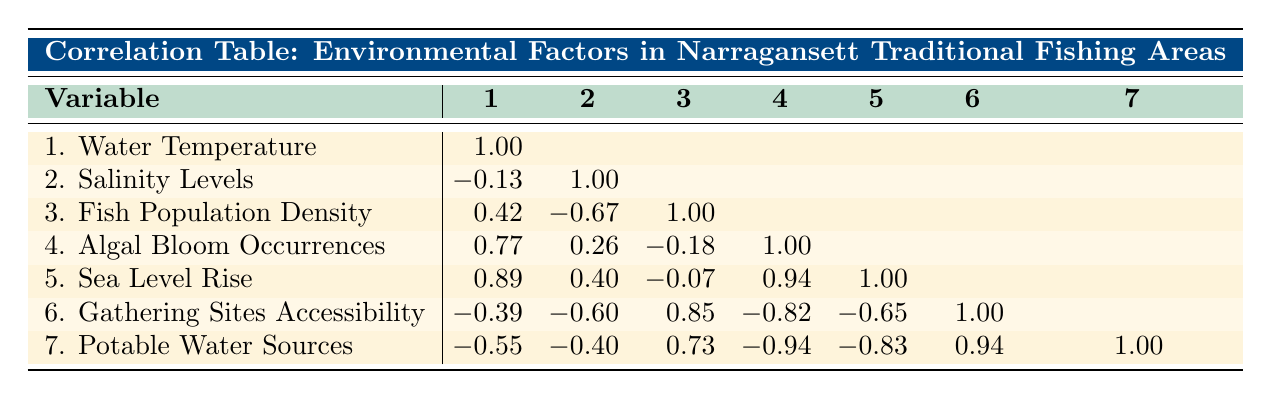What's the fish population density in Narrow River? In the table, under the column for fish population density, I see that the value corresponding to Narrow River is 200 fish per square mile.
Answer: 200 What is the salinity level of Point Judith Pond? Point Judith Pond shows a salinity level of 27 PSU in the salinity levels column of the table.
Answer: 27 Which fishing area has the highest water temperature? By observing the water temperature values for each fishing area, Matunuck Beach has the highest water temperature at 67 degrees Fahrenheit.
Answer: 67 Is there a correlation between fish population density and gathering sites accessibility? Looking at the correlation table, I see that the correlation coefficient between fish population density and gathering sites accessibility is 0.85, indicating a strong positive correlation.
Answer: Yes What is the sea level rise associated with Narragansett Bay? I can find the value for sea level rise next to Narragansett Bay under the sea level rise column, which is 1.2 feet per year.
Answer: 1.2 What is the average number of algal bloom occurrences across all fishing areas? I can calculate the average by adding the occurrences: (3 + 2 + 1 + 4) = 10. Since there are 4 areas, I divide by 4, giving an average of 10/4 = 2.5.
Answer: 2.5 Does salinity have a negative correlation with fish population density? Checking the correlation between salinity levels and fish population density, I see a value of -0.67, which indicates a moderate negative correlation.
Answer: Yes Which fishing area has the least accessible gathering sites? The table shows that Point Judith Pond has the lowest gathering sites accessibility score of 3.
Answer: Point Judith Pond What is the total number of potable water sources available in all the fishing areas? By summing the potable water sources: (5 + 4 + 6 + 3) = 18. Thus, the total number of accessible potable water sources is 18.
Answer: 18 What is the correlation between sea level rise and algal bloom occurrences? The correlation table indicates a value of 0.94 between sea level rise and algal bloom occurrences, indicating a strong positive correlation.
Answer: 0.94 